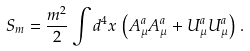<formula> <loc_0><loc_0><loc_500><loc_500>S _ { m } = \frac { m ^ { 2 } } { 2 } \int d ^ { 4 } x \, \left ( A ^ { a } _ { \mu } A ^ { a } _ { \mu } + U ^ { a } _ { \mu } U ^ { a } _ { \mu } \right ) \, .</formula> 